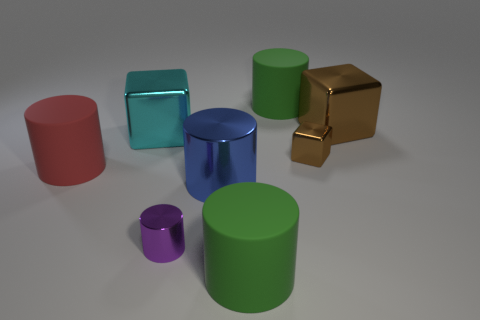Is there a pattern to the sizes of the different colored objects? Upon careful examination, it appears that the objects are not organized by size in any discernible pattern. The arrangement seems rather arbitrary, with objects of various sizes dotting the landscape without any apparent systematic approach to their placement. 